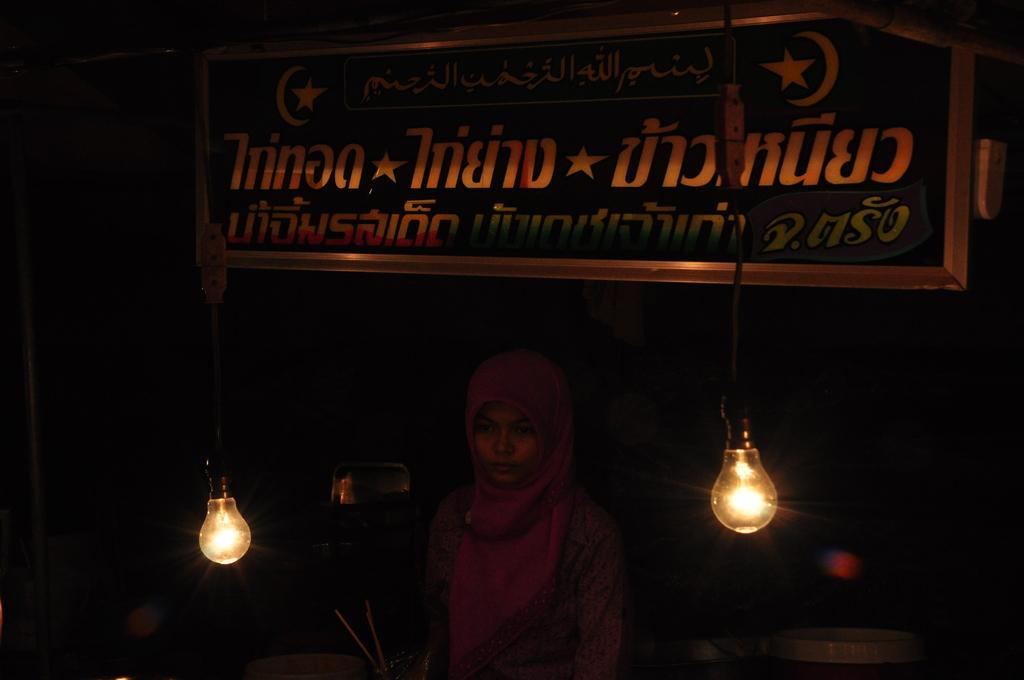Who or what is present in the image? There is a person in the image. What is written or displayed on the board in the image? There is a board with text in the image. What type of lighting is present in the image? There are lights hanging in the image. How would you describe the overall lighting in the image? The background of the image is dark. What type of stew is being served in the image? There is no stew present in the image. How many bikes are visible in the image? There are no bikes present in the image. 